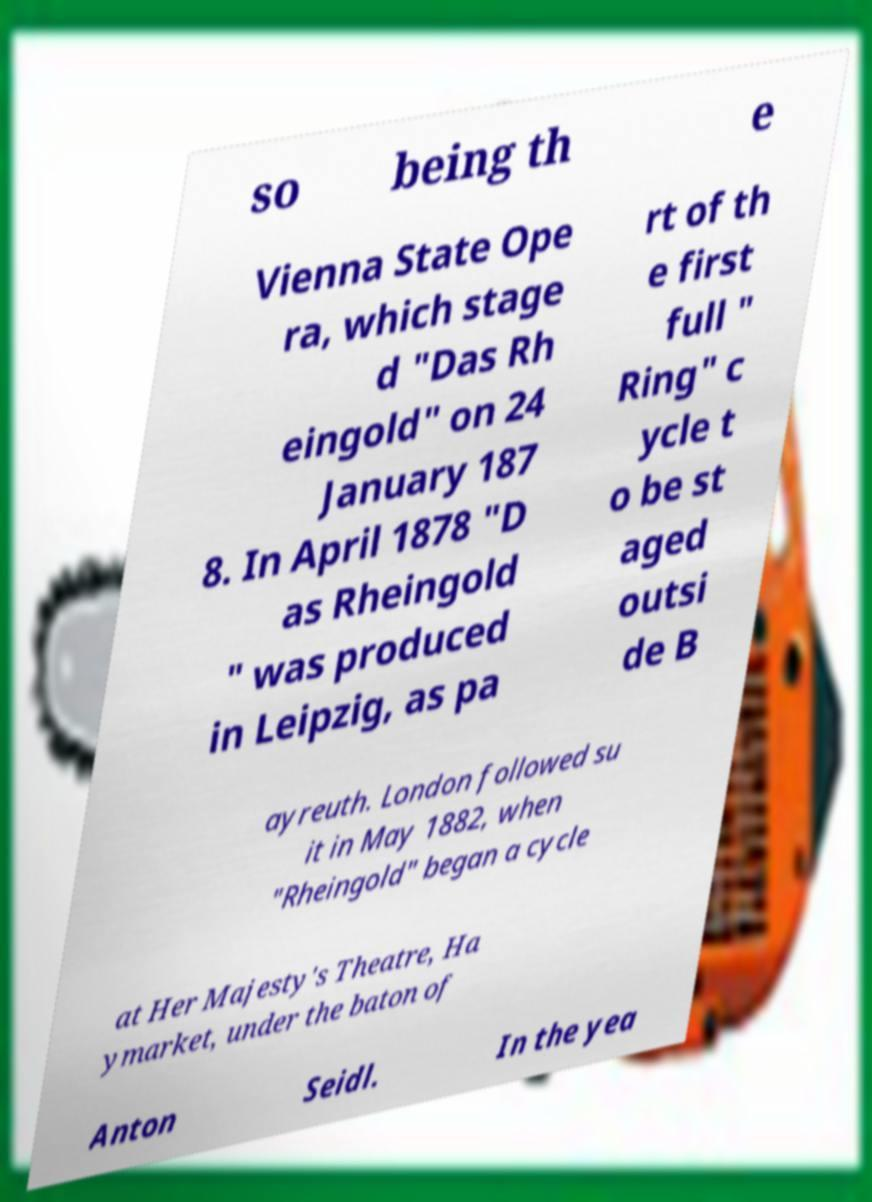Could you extract and type out the text from this image? so being th e Vienna State Ope ra, which stage d "Das Rh eingold" on 24 January 187 8. In April 1878 "D as Rheingold " was produced in Leipzig, as pa rt of th e first full " Ring" c ycle t o be st aged outsi de B ayreuth. London followed su it in May 1882, when "Rheingold" began a cycle at Her Majesty's Theatre, Ha ymarket, under the baton of Anton Seidl. In the yea 